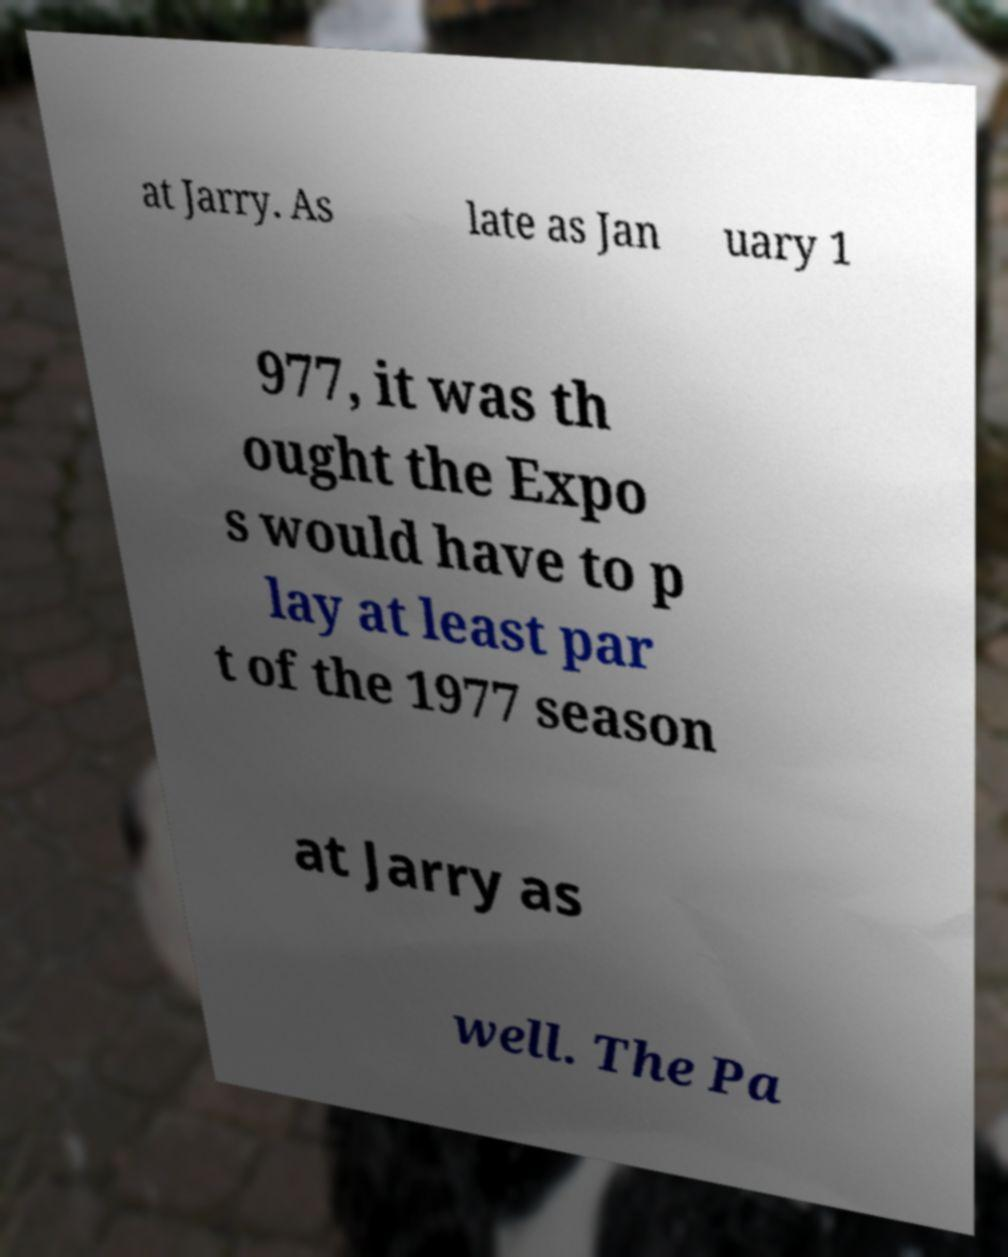Could you assist in decoding the text presented in this image and type it out clearly? at Jarry. As late as Jan uary 1 977, it was th ought the Expo s would have to p lay at least par t of the 1977 season at Jarry as well. The Pa 